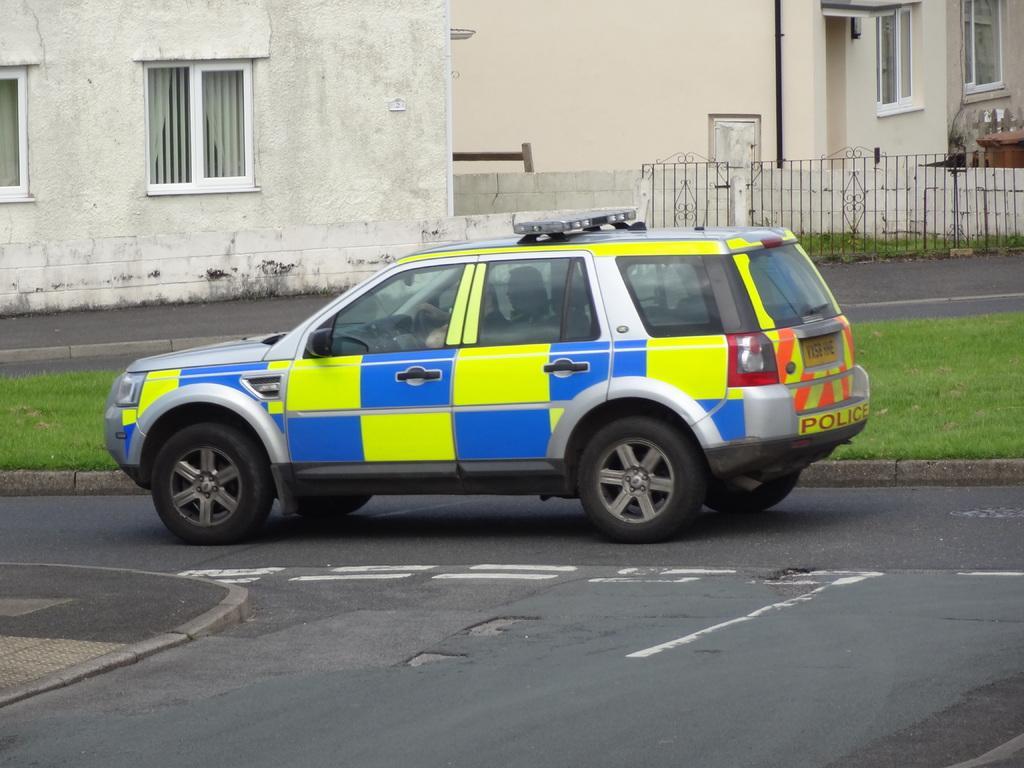How would you summarize this image in a sentence or two? In this image we can see a car is on the road. Here we can see the grass, houses and the fence in the background. 